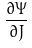<formula> <loc_0><loc_0><loc_500><loc_500>\frac { \partial \Psi } { \partial J }</formula> 